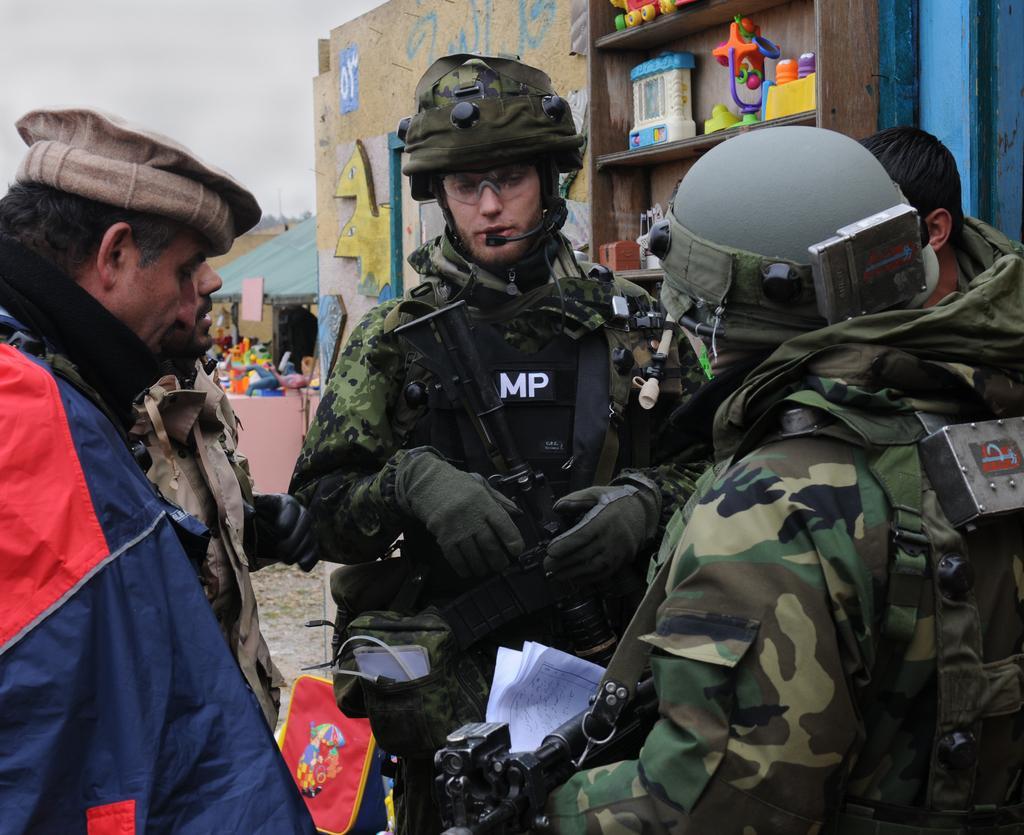Please provide a concise description of this image. In this image I can see few people are wearing military dresses and holding guns and few people are wearing different color dresses. Back I can see few shed, few objects on the cupboard and colorful wall. The sky is in white color. 